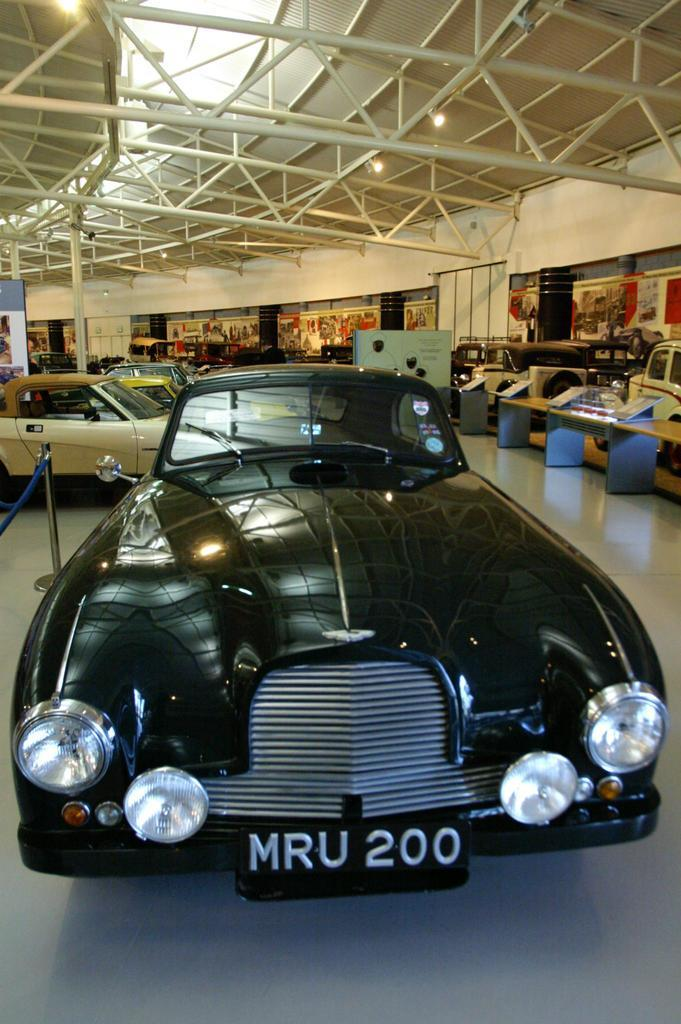What color is the car in the image? The car in the image is black. What can be seen in front of the car in the image? There is a rope barrier in front of the car. What can be seen in the background of the image? In the background of the image, there are cars, boards, a table, iron rods, and lights. What type of instrument is being played in the background of the image? There is no instrument being played in the background of the image. Is there a birthday celebration happening in the image? There is no indication of a birthday celebration in the image. 